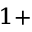Convert formula to latex. <formula><loc_0><loc_0><loc_500><loc_500>^ { 1 + }</formula> 